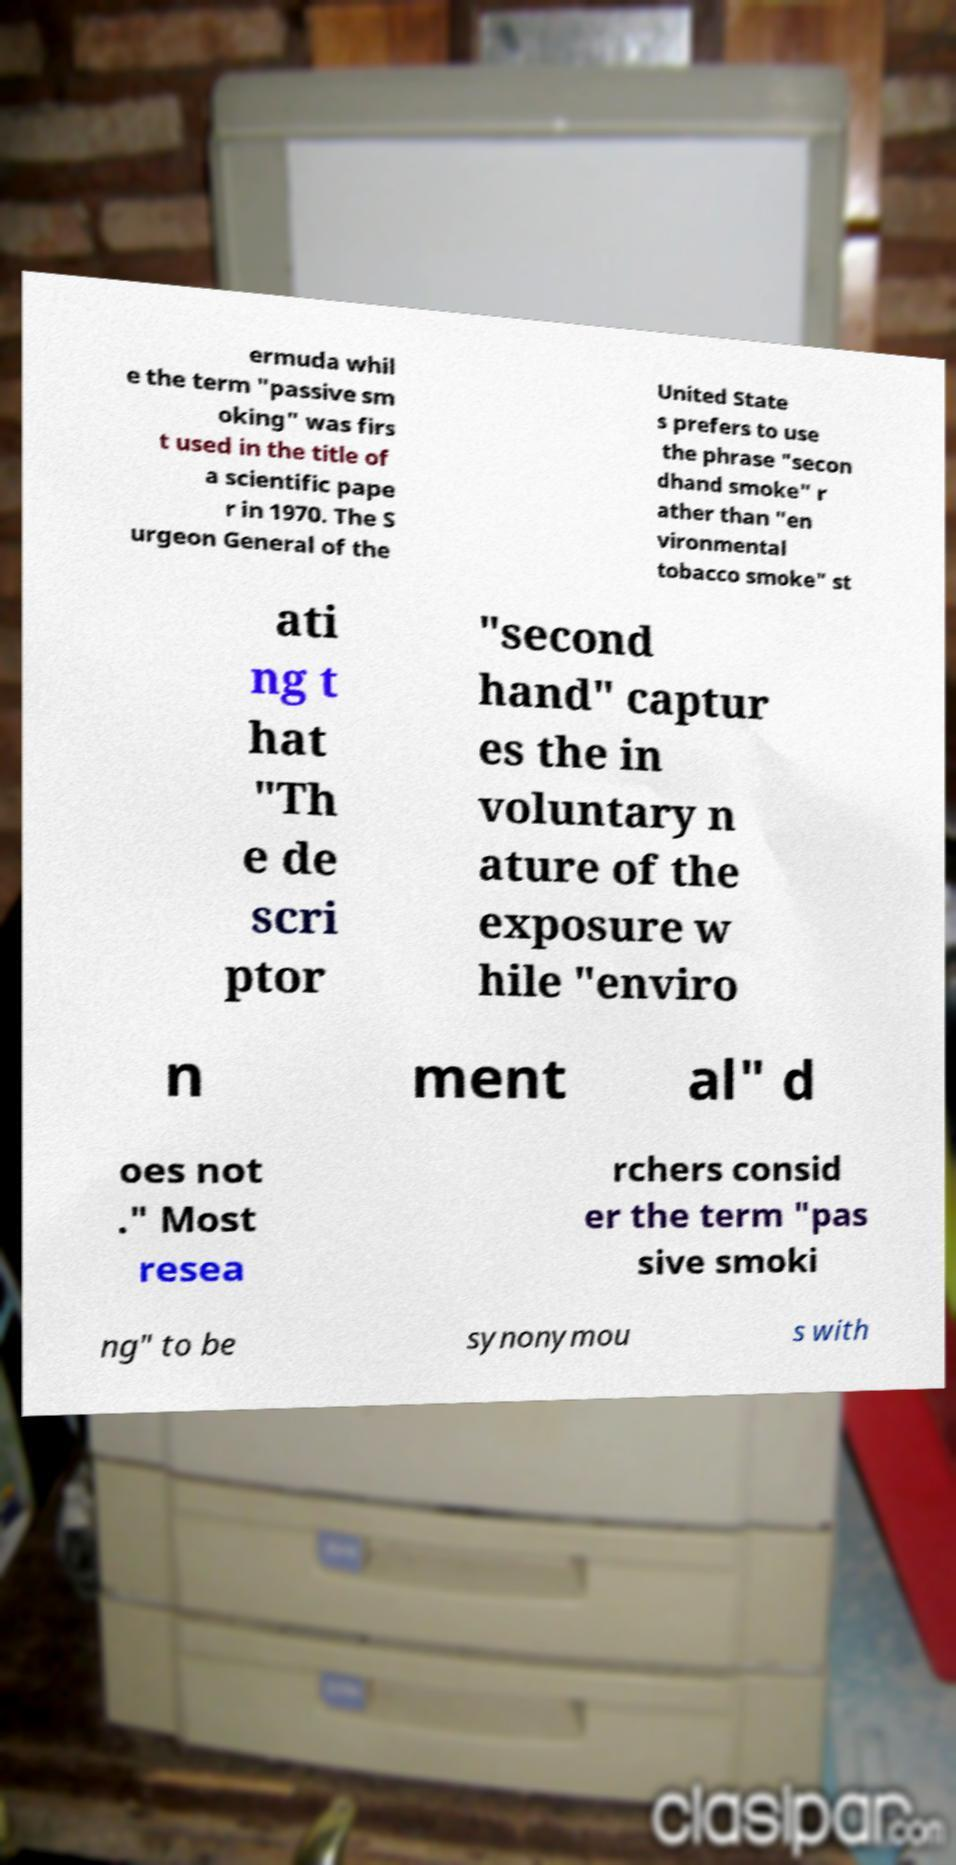What messages or text are displayed in this image? I need them in a readable, typed format. ermuda whil e the term "passive sm oking" was firs t used in the title of a scientific pape r in 1970. The S urgeon General of the United State s prefers to use the phrase "secon dhand smoke" r ather than "en vironmental tobacco smoke" st ati ng t hat "Th e de scri ptor "second hand" captur es the in voluntary n ature of the exposure w hile "enviro n ment al" d oes not ." Most resea rchers consid er the term "pas sive smoki ng" to be synonymou s with 